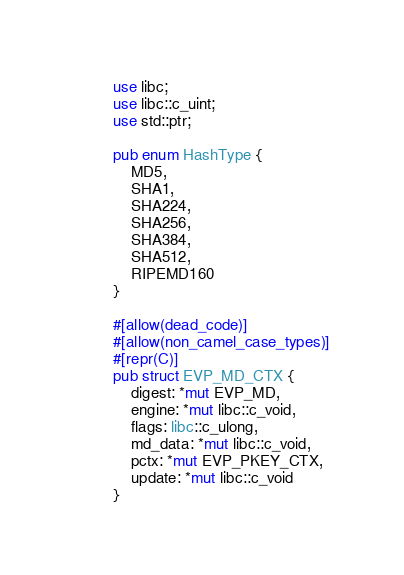Convert code to text. <code><loc_0><loc_0><loc_500><loc_500><_Rust_>use libc;
use libc::c_uint;
use std::ptr;

pub enum HashType {
    MD5,
    SHA1,
    SHA224,
    SHA256,
    SHA384,
    SHA512,
    RIPEMD160
}

#[allow(dead_code)]
#[allow(non_camel_case_types)]
#[repr(C)]
pub struct EVP_MD_CTX {
    digest: *mut EVP_MD,
    engine: *mut libc::c_void,
    flags: libc::c_ulong,
    md_data: *mut libc::c_void,
    pctx: *mut EVP_PKEY_CTX,
    update: *mut libc::c_void
}
</code> 